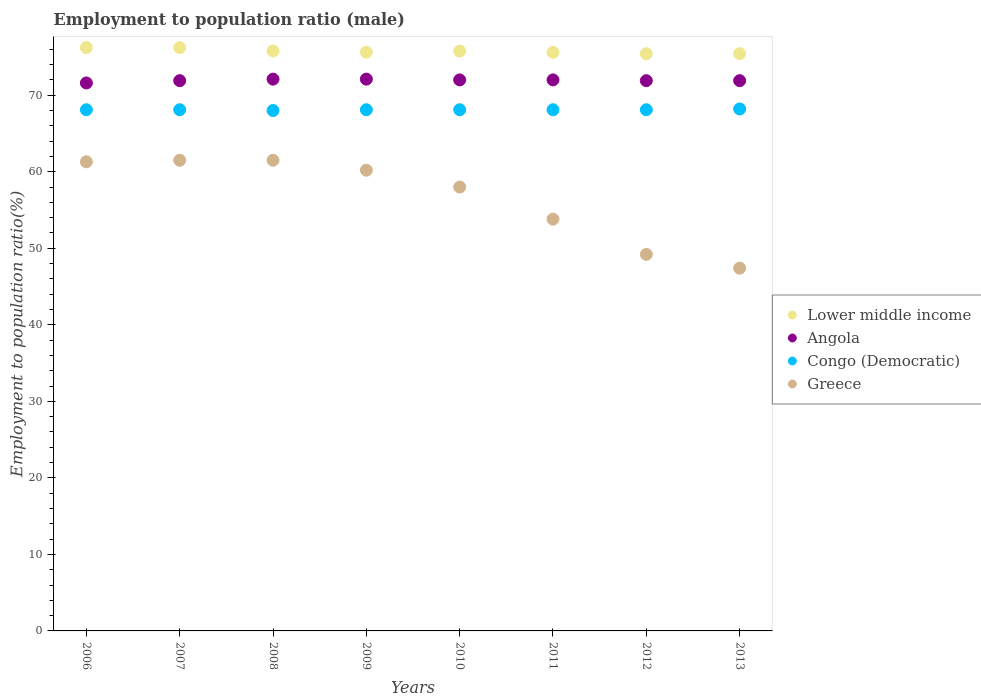What is the employment to population ratio in Greece in 2007?
Keep it short and to the point. 61.5. Across all years, what is the maximum employment to population ratio in Greece?
Offer a terse response. 61.5. Across all years, what is the minimum employment to population ratio in Lower middle income?
Provide a succinct answer. 75.42. In which year was the employment to population ratio in Angola minimum?
Your answer should be compact. 2006. What is the total employment to population ratio in Greece in the graph?
Provide a short and direct response. 452.9. What is the difference between the employment to population ratio in Lower middle income in 2009 and that in 2011?
Keep it short and to the point. 0.02. What is the difference between the employment to population ratio in Congo (Democratic) in 2013 and the employment to population ratio in Greece in 2012?
Keep it short and to the point. 19. What is the average employment to population ratio in Angola per year?
Provide a short and direct response. 71.94. In the year 2013, what is the difference between the employment to population ratio in Congo (Democratic) and employment to population ratio in Angola?
Offer a very short reply. -3.7. What is the ratio of the employment to population ratio in Congo (Democratic) in 2006 to that in 2008?
Your answer should be compact. 1. What is the difference between the highest and the second highest employment to population ratio in Congo (Democratic)?
Offer a terse response. 0.1. In how many years, is the employment to population ratio in Greece greater than the average employment to population ratio in Greece taken over all years?
Provide a succinct answer. 5. Does the employment to population ratio in Congo (Democratic) monotonically increase over the years?
Give a very brief answer. No. How many dotlines are there?
Your answer should be very brief. 4. Are the values on the major ticks of Y-axis written in scientific E-notation?
Your response must be concise. No. Does the graph contain any zero values?
Give a very brief answer. No. Where does the legend appear in the graph?
Give a very brief answer. Center right. How many legend labels are there?
Offer a very short reply. 4. What is the title of the graph?
Your answer should be compact. Employment to population ratio (male). Does "Virgin Islands" appear as one of the legend labels in the graph?
Provide a short and direct response. No. What is the label or title of the X-axis?
Provide a short and direct response. Years. What is the Employment to population ratio(%) of Lower middle income in 2006?
Offer a very short reply. 76.22. What is the Employment to population ratio(%) of Angola in 2006?
Offer a very short reply. 71.6. What is the Employment to population ratio(%) in Congo (Democratic) in 2006?
Ensure brevity in your answer.  68.1. What is the Employment to population ratio(%) in Greece in 2006?
Offer a very short reply. 61.3. What is the Employment to population ratio(%) in Lower middle income in 2007?
Keep it short and to the point. 76.22. What is the Employment to population ratio(%) of Angola in 2007?
Your answer should be compact. 71.9. What is the Employment to population ratio(%) in Congo (Democratic) in 2007?
Your answer should be compact. 68.1. What is the Employment to population ratio(%) of Greece in 2007?
Provide a short and direct response. 61.5. What is the Employment to population ratio(%) in Lower middle income in 2008?
Your answer should be compact. 75.78. What is the Employment to population ratio(%) in Angola in 2008?
Offer a very short reply. 72.1. What is the Employment to population ratio(%) of Greece in 2008?
Provide a succinct answer. 61.5. What is the Employment to population ratio(%) in Lower middle income in 2009?
Provide a short and direct response. 75.62. What is the Employment to population ratio(%) in Angola in 2009?
Offer a very short reply. 72.1. What is the Employment to population ratio(%) in Congo (Democratic) in 2009?
Keep it short and to the point. 68.1. What is the Employment to population ratio(%) in Greece in 2009?
Offer a very short reply. 60.2. What is the Employment to population ratio(%) in Lower middle income in 2010?
Provide a succinct answer. 75.76. What is the Employment to population ratio(%) of Congo (Democratic) in 2010?
Provide a short and direct response. 68.1. What is the Employment to population ratio(%) of Lower middle income in 2011?
Make the answer very short. 75.6. What is the Employment to population ratio(%) in Angola in 2011?
Provide a succinct answer. 72. What is the Employment to population ratio(%) of Congo (Democratic) in 2011?
Your answer should be compact. 68.1. What is the Employment to population ratio(%) of Greece in 2011?
Provide a short and direct response. 53.8. What is the Employment to population ratio(%) in Lower middle income in 2012?
Your response must be concise. 75.42. What is the Employment to population ratio(%) in Angola in 2012?
Your answer should be very brief. 71.9. What is the Employment to population ratio(%) in Congo (Democratic) in 2012?
Your answer should be very brief. 68.1. What is the Employment to population ratio(%) in Greece in 2012?
Provide a short and direct response. 49.2. What is the Employment to population ratio(%) in Lower middle income in 2013?
Keep it short and to the point. 75.43. What is the Employment to population ratio(%) of Angola in 2013?
Your response must be concise. 71.9. What is the Employment to population ratio(%) of Congo (Democratic) in 2013?
Provide a short and direct response. 68.2. What is the Employment to population ratio(%) of Greece in 2013?
Provide a succinct answer. 47.4. Across all years, what is the maximum Employment to population ratio(%) of Lower middle income?
Ensure brevity in your answer.  76.22. Across all years, what is the maximum Employment to population ratio(%) of Angola?
Your response must be concise. 72.1. Across all years, what is the maximum Employment to population ratio(%) in Congo (Democratic)?
Your response must be concise. 68.2. Across all years, what is the maximum Employment to population ratio(%) of Greece?
Keep it short and to the point. 61.5. Across all years, what is the minimum Employment to population ratio(%) of Lower middle income?
Offer a very short reply. 75.42. Across all years, what is the minimum Employment to population ratio(%) of Angola?
Your response must be concise. 71.6. Across all years, what is the minimum Employment to population ratio(%) in Congo (Democratic)?
Provide a short and direct response. 68. Across all years, what is the minimum Employment to population ratio(%) of Greece?
Your answer should be compact. 47.4. What is the total Employment to population ratio(%) of Lower middle income in the graph?
Provide a short and direct response. 606.04. What is the total Employment to population ratio(%) of Angola in the graph?
Provide a succinct answer. 575.5. What is the total Employment to population ratio(%) in Congo (Democratic) in the graph?
Ensure brevity in your answer.  544.8. What is the total Employment to population ratio(%) in Greece in the graph?
Your answer should be very brief. 452.9. What is the difference between the Employment to population ratio(%) of Lower middle income in 2006 and that in 2007?
Provide a short and direct response. 0. What is the difference between the Employment to population ratio(%) in Angola in 2006 and that in 2007?
Provide a succinct answer. -0.3. What is the difference between the Employment to population ratio(%) in Lower middle income in 2006 and that in 2008?
Make the answer very short. 0.44. What is the difference between the Employment to population ratio(%) of Congo (Democratic) in 2006 and that in 2008?
Give a very brief answer. 0.1. What is the difference between the Employment to population ratio(%) of Lower middle income in 2006 and that in 2009?
Make the answer very short. 0.6. What is the difference between the Employment to population ratio(%) in Angola in 2006 and that in 2009?
Your answer should be very brief. -0.5. What is the difference between the Employment to population ratio(%) in Lower middle income in 2006 and that in 2010?
Give a very brief answer. 0.46. What is the difference between the Employment to population ratio(%) in Greece in 2006 and that in 2010?
Your answer should be very brief. 3.3. What is the difference between the Employment to population ratio(%) in Lower middle income in 2006 and that in 2011?
Your response must be concise. 0.62. What is the difference between the Employment to population ratio(%) of Angola in 2006 and that in 2011?
Offer a very short reply. -0.4. What is the difference between the Employment to population ratio(%) in Congo (Democratic) in 2006 and that in 2011?
Offer a terse response. 0. What is the difference between the Employment to population ratio(%) in Greece in 2006 and that in 2011?
Provide a short and direct response. 7.5. What is the difference between the Employment to population ratio(%) of Lower middle income in 2006 and that in 2012?
Offer a terse response. 0.8. What is the difference between the Employment to population ratio(%) of Greece in 2006 and that in 2012?
Your response must be concise. 12.1. What is the difference between the Employment to population ratio(%) of Lower middle income in 2006 and that in 2013?
Offer a very short reply. 0.79. What is the difference between the Employment to population ratio(%) in Angola in 2006 and that in 2013?
Your answer should be very brief. -0.3. What is the difference between the Employment to population ratio(%) of Greece in 2006 and that in 2013?
Provide a succinct answer. 13.9. What is the difference between the Employment to population ratio(%) of Lower middle income in 2007 and that in 2008?
Offer a terse response. 0.44. What is the difference between the Employment to population ratio(%) of Greece in 2007 and that in 2008?
Provide a short and direct response. 0. What is the difference between the Employment to population ratio(%) of Lower middle income in 2007 and that in 2009?
Ensure brevity in your answer.  0.6. What is the difference between the Employment to population ratio(%) in Congo (Democratic) in 2007 and that in 2009?
Offer a terse response. 0. What is the difference between the Employment to population ratio(%) in Lower middle income in 2007 and that in 2010?
Offer a very short reply. 0.45. What is the difference between the Employment to population ratio(%) of Angola in 2007 and that in 2010?
Keep it short and to the point. -0.1. What is the difference between the Employment to population ratio(%) in Congo (Democratic) in 2007 and that in 2010?
Provide a succinct answer. 0. What is the difference between the Employment to population ratio(%) in Greece in 2007 and that in 2010?
Ensure brevity in your answer.  3.5. What is the difference between the Employment to population ratio(%) of Lower middle income in 2007 and that in 2011?
Your response must be concise. 0.62. What is the difference between the Employment to population ratio(%) of Angola in 2007 and that in 2011?
Make the answer very short. -0.1. What is the difference between the Employment to population ratio(%) in Lower middle income in 2007 and that in 2012?
Your answer should be compact. 0.8. What is the difference between the Employment to population ratio(%) in Angola in 2007 and that in 2012?
Provide a short and direct response. 0. What is the difference between the Employment to population ratio(%) in Lower middle income in 2007 and that in 2013?
Your answer should be compact. 0.79. What is the difference between the Employment to population ratio(%) of Congo (Democratic) in 2007 and that in 2013?
Your answer should be compact. -0.1. What is the difference between the Employment to population ratio(%) in Greece in 2007 and that in 2013?
Make the answer very short. 14.1. What is the difference between the Employment to population ratio(%) in Lower middle income in 2008 and that in 2009?
Provide a succinct answer. 0.16. What is the difference between the Employment to population ratio(%) in Angola in 2008 and that in 2009?
Provide a short and direct response. 0. What is the difference between the Employment to population ratio(%) of Greece in 2008 and that in 2009?
Give a very brief answer. 1.3. What is the difference between the Employment to population ratio(%) of Lower middle income in 2008 and that in 2010?
Offer a very short reply. 0.02. What is the difference between the Employment to population ratio(%) of Angola in 2008 and that in 2010?
Your response must be concise. 0.1. What is the difference between the Employment to population ratio(%) of Congo (Democratic) in 2008 and that in 2010?
Ensure brevity in your answer.  -0.1. What is the difference between the Employment to population ratio(%) in Greece in 2008 and that in 2010?
Offer a terse response. 3.5. What is the difference between the Employment to population ratio(%) of Lower middle income in 2008 and that in 2011?
Provide a short and direct response. 0.18. What is the difference between the Employment to population ratio(%) in Angola in 2008 and that in 2011?
Ensure brevity in your answer.  0.1. What is the difference between the Employment to population ratio(%) of Lower middle income in 2008 and that in 2012?
Provide a short and direct response. 0.36. What is the difference between the Employment to population ratio(%) of Congo (Democratic) in 2008 and that in 2012?
Provide a short and direct response. -0.1. What is the difference between the Employment to population ratio(%) of Lower middle income in 2008 and that in 2013?
Make the answer very short. 0.35. What is the difference between the Employment to population ratio(%) of Lower middle income in 2009 and that in 2010?
Your answer should be very brief. -0.15. What is the difference between the Employment to population ratio(%) in Lower middle income in 2009 and that in 2011?
Your answer should be compact. 0.02. What is the difference between the Employment to population ratio(%) of Congo (Democratic) in 2009 and that in 2011?
Provide a succinct answer. 0. What is the difference between the Employment to population ratio(%) of Greece in 2009 and that in 2011?
Your answer should be very brief. 6.4. What is the difference between the Employment to population ratio(%) of Lower middle income in 2009 and that in 2012?
Ensure brevity in your answer.  0.2. What is the difference between the Employment to population ratio(%) of Congo (Democratic) in 2009 and that in 2012?
Provide a succinct answer. 0. What is the difference between the Employment to population ratio(%) of Lower middle income in 2009 and that in 2013?
Offer a very short reply. 0.19. What is the difference between the Employment to population ratio(%) of Lower middle income in 2010 and that in 2011?
Provide a short and direct response. 0.16. What is the difference between the Employment to population ratio(%) in Angola in 2010 and that in 2011?
Give a very brief answer. 0. What is the difference between the Employment to population ratio(%) of Lower middle income in 2010 and that in 2012?
Offer a terse response. 0.34. What is the difference between the Employment to population ratio(%) in Lower middle income in 2010 and that in 2013?
Your answer should be very brief. 0.34. What is the difference between the Employment to population ratio(%) in Angola in 2010 and that in 2013?
Your response must be concise. 0.1. What is the difference between the Employment to population ratio(%) in Congo (Democratic) in 2010 and that in 2013?
Your answer should be compact. -0.1. What is the difference between the Employment to population ratio(%) in Greece in 2010 and that in 2013?
Provide a short and direct response. 10.6. What is the difference between the Employment to population ratio(%) of Lower middle income in 2011 and that in 2012?
Your answer should be very brief. 0.18. What is the difference between the Employment to population ratio(%) in Greece in 2011 and that in 2012?
Provide a succinct answer. 4.6. What is the difference between the Employment to population ratio(%) of Lower middle income in 2011 and that in 2013?
Offer a very short reply. 0.17. What is the difference between the Employment to population ratio(%) of Congo (Democratic) in 2011 and that in 2013?
Ensure brevity in your answer.  -0.1. What is the difference between the Employment to population ratio(%) in Lower middle income in 2012 and that in 2013?
Your answer should be very brief. -0.01. What is the difference between the Employment to population ratio(%) of Congo (Democratic) in 2012 and that in 2013?
Provide a short and direct response. -0.1. What is the difference between the Employment to population ratio(%) in Lower middle income in 2006 and the Employment to population ratio(%) in Angola in 2007?
Give a very brief answer. 4.32. What is the difference between the Employment to population ratio(%) of Lower middle income in 2006 and the Employment to population ratio(%) of Congo (Democratic) in 2007?
Provide a short and direct response. 8.12. What is the difference between the Employment to population ratio(%) in Lower middle income in 2006 and the Employment to population ratio(%) in Greece in 2007?
Keep it short and to the point. 14.72. What is the difference between the Employment to population ratio(%) in Angola in 2006 and the Employment to population ratio(%) in Congo (Democratic) in 2007?
Offer a very short reply. 3.5. What is the difference between the Employment to population ratio(%) of Congo (Democratic) in 2006 and the Employment to population ratio(%) of Greece in 2007?
Provide a short and direct response. 6.6. What is the difference between the Employment to population ratio(%) in Lower middle income in 2006 and the Employment to population ratio(%) in Angola in 2008?
Offer a very short reply. 4.12. What is the difference between the Employment to population ratio(%) of Lower middle income in 2006 and the Employment to population ratio(%) of Congo (Democratic) in 2008?
Your answer should be compact. 8.22. What is the difference between the Employment to population ratio(%) of Lower middle income in 2006 and the Employment to population ratio(%) of Greece in 2008?
Give a very brief answer. 14.72. What is the difference between the Employment to population ratio(%) in Angola in 2006 and the Employment to population ratio(%) in Congo (Democratic) in 2008?
Make the answer very short. 3.6. What is the difference between the Employment to population ratio(%) in Congo (Democratic) in 2006 and the Employment to population ratio(%) in Greece in 2008?
Your answer should be compact. 6.6. What is the difference between the Employment to population ratio(%) of Lower middle income in 2006 and the Employment to population ratio(%) of Angola in 2009?
Ensure brevity in your answer.  4.12. What is the difference between the Employment to population ratio(%) in Lower middle income in 2006 and the Employment to population ratio(%) in Congo (Democratic) in 2009?
Your answer should be compact. 8.12. What is the difference between the Employment to population ratio(%) in Lower middle income in 2006 and the Employment to population ratio(%) in Greece in 2009?
Provide a succinct answer. 16.02. What is the difference between the Employment to population ratio(%) of Angola in 2006 and the Employment to population ratio(%) of Congo (Democratic) in 2009?
Your answer should be compact. 3.5. What is the difference between the Employment to population ratio(%) in Congo (Democratic) in 2006 and the Employment to population ratio(%) in Greece in 2009?
Your answer should be very brief. 7.9. What is the difference between the Employment to population ratio(%) of Lower middle income in 2006 and the Employment to population ratio(%) of Angola in 2010?
Provide a succinct answer. 4.22. What is the difference between the Employment to population ratio(%) in Lower middle income in 2006 and the Employment to population ratio(%) in Congo (Democratic) in 2010?
Your answer should be compact. 8.12. What is the difference between the Employment to population ratio(%) of Lower middle income in 2006 and the Employment to population ratio(%) of Greece in 2010?
Offer a very short reply. 18.22. What is the difference between the Employment to population ratio(%) of Lower middle income in 2006 and the Employment to population ratio(%) of Angola in 2011?
Your answer should be compact. 4.22. What is the difference between the Employment to population ratio(%) of Lower middle income in 2006 and the Employment to population ratio(%) of Congo (Democratic) in 2011?
Your answer should be compact. 8.12. What is the difference between the Employment to population ratio(%) in Lower middle income in 2006 and the Employment to population ratio(%) in Greece in 2011?
Offer a very short reply. 22.42. What is the difference between the Employment to population ratio(%) of Congo (Democratic) in 2006 and the Employment to population ratio(%) of Greece in 2011?
Keep it short and to the point. 14.3. What is the difference between the Employment to population ratio(%) in Lower middle income in 2006 and the Employment to population ratio(%) in Angola in 2012?
Your answer should be compact. 4.32. What is the difference between the Employment to population ratio(%) in Lower middle income in 2006 and the Employment to population ratio(%) in Congo (Democratic) in 2012?
Provide a succinct answer. 8.12. What is the difference between the Employment to population ratio(%) of Lower middle income in 2006 and the Employment to population ratio(%) of Greece in 2012?
Give a very brief answer. 27.02. What is the difference between the Employment to population ratio(%) of Angola in 2006 and the Employment to population ratio(%) of Greece in 2012?
Ensure brevity in your answer.  22.4. What is the difference between the Employment to population ratio(%) in Congo (Democratic) in 2006 and the Employment to population ratio(%) in Greece in 2012?
Your answer should be compact. 18.9. What is the difference between the Employment to population ratio(%) of Lower middle income in 2006 and the Employment to population ratio(%) of Angola in 2013?
Your answer should be very brief. 4.32. What is the difference between the Employment to population ratio(%) in Lower middle income in 2006 and the Employment to population ratio(%) in Congo (Democratic) in 2013?
Your answer should be compact. 8.02. What is the difference between the Employment to population ratio(%) in Lower middle income in 2006 and the Employment to population ratio(%) in Greece in 2013?
Ensure brevity in your answer.  28.82. What is the difference between the Employment to population ratio(%) in Angola in 2006 and the Employment to population ratio(%) in Congo (Democratic) in 2013?
Give a very brief answer. 3.4. What is the difference between the Employment to population ratio(%) in Angola in 2006 and the Employment to population ratio(%) in Greece in 2013?
Make the answer very short. 24.2. What is the difference between the Employment to population ratio(%) of Congo (Democratic) in 2006 and the Employment to population ratio(%) of Greece in 2013?
Your answer should be compact. 20.7. What is the difference between the Employment to population ratio(%) of Lower middle income in 2007 and the Employment to population ratio(%) of Angola in 2008?
Provide a succinct answer. 4.12. What is the difference between the Employment to population ratio(%) of Lower middle income in 2007 and the Employment to population ratio(%) of Congo (Democratic) in 2008?
Your response must be concise. 8.22. What is the difference between the Employment to population ratio(%) in Lower middle income in 2007 and the Employment to population ratio(%) in Greece in 2008?
Offer a very short reply. 14.72. What is the difference between the Employment to population ratio(%) of Angola in 2007 and the Employment to population ratio(%) of Congo (Democratic) in 2008?
Ensure brevity in your answer.  3.9. What is the difference between the Employment to population ratio(%) in Lower middle income in 2007 and the Employment to population ratio(%) in Angola in 2009?
Give a very brief answer. 4.12. What is the difference between the Employment to population ratio(%) in Lower middle income in 2007 and the Employment to population ratio(%) in Congo (Democratic) in 2009?
Give a very brief answer. 8.12. What is the difference between the Employment to population ratio(%) in Lower middle income in 2007 and the Employment to population ratio(%) in Greece in 2009?
Make the answer very short. 16.02. What is the difference between the Employment to population ratio(%) in Angola in 2007 and the Employment to population ratio(%) in Greece in 2009?
Keep it short and to the point. 11.7. What is the difference between the Employment to population ratio(%) of Lower middle income in 2007 and the Employment to population ratio(%) of Angola in 2010?
Give a very brief answer. 4.22. What is the difference between the Employment to population ratio(%) in Lower middle income in 2007 and the Employment to population ratio(%) in Congo (Democratic) in 2010?
Your answer should be compact. 8.12. What is the difference between the Employment to population ratio(%) in Lower middle income in 2007 and the Employment to population ratio(%) in Greece in 2010?
Your answer should be compact. 18.22. What is the difference between the Employment to population ratio(%) of Angola in 2007 and the Employment to population ratio(%) of Congo (Democratic) in 2010?
Ensure brevity in your answer.  3.8. What is the difference between the Employment to population ratio(%) in Angola in 2007 and the Employment to population ratio(%) in Greece in 2010?
Your answer should be very brief. 13.9. What is the difference between the Employment to population ratio(%) of Congo (Democratic) in 2007 and the Employment to population ratio(%) of Greece in 2010?
Provide a short and direct response. 10.1. What is the difference between the Employment to population ratio(%) in Lower middle income in 2007 and the Employment to population ratio(%) in Angola in 2011?
Make the answer very short. 4.22. What is the difference between the Employment to population ratio(%) in Lower middle income in 2007 and the Employment to population ratio(%) in Congo (Democratic) in 2011?
Give a very brief answer. 8.12. What is the difference between the Employment to population ratio(%) in Lower middle income in 2007 and the Employment to population ratio(%) in Greece in 2011?
Provide a short and direct response. 22.42. What is the difference between the Employment to population ratio(%) in Congo (Democratic) in 2007 and the Employment to population ratio(%) in Greece in 2011?
Offer a very short reply. 14.3. What is the difference between the Employment to population ratio(%) of Lower middle income in 2007 and the Employment to population ratio(%) of Angola in 2012?
Your response must be concise. 4.32. What is the difference between the Employment to population ratio(%) in Lower middle income in 2007 and the Employment to population ratio(%) in Congo (Democratic) in 2012?
Ensure brevity in your answer.  8.12. What is the difference between the Employment to population ratio(%) of Lower middle income in 2007 and the Employment to population ratio(%) of Greece in 2012?
Offer a terse response. 27.02. What is the difference between the Employment to population ratio(%) in Angola in 2007 and the Employment to population ratio(%) in Congo (Democratic) in 2012?
Provide a short and direct response. 3.8. What is the difference between the Employment to population ratio(%) in Angola in 2007 and the Employment to population ratio(%) in Greece in 2012?
Your answer should be very brief. 22.7. What is the difference between the Employment to population ratio(%) of Lower middle income in 2007 and the Employment to population ratio(%) of Angola in 2013?
Offer a very short reply. 4.32. What is the difference between the Employment to population ratio(%) in Lower middle income in 2007 and the Employment to population ratio(%) in Congo (Democratic) in 2013?
Provide a short and direct response. 8.02. What is the difference between the Employment to population ratio(%) in Lower middle income in 2007 and the Employment to population ratio(%) in Greece in 2013?
Ensure brevity in your answer.  28.82. What is the difference between the Employment to population ratio(%) in Congo (Democratic) in 2007 and the Employment to population ratio(%) in Greece in 2013?
Offer a very short reply. 20.7. What is the difference between the Employment to population ratio(%) of Lower middle income in 2008 and the Employment to population ratio(%) of Angola in 2009?
Offer a very short reply. 3.68. What is the difference between the Employment to population ratio(%) in Lower middle income in 2008 and the Employment to population ratio(%) in Congo (Democratic) in 2009?
Keep it short and to the point. 7.68. What is the difference between the Employment to population ratio(%) in Lower middle income in 2008 and the Employment to population ratio(%) in Greece in 2009?
Your response must be concise. 15.58. What is the difference between the Employment to population ratio(%) in Angola in 2008 and the Employment to population ratio(%) in Congo (Democratic) in 2009?
Ensure brevity in your answer.  4. What is the difference between the Employment to population ratio(%) in Lower middle income in 2008 and the Employment to population ratio(%) in Angola in 2010?
Offer a very short reply. 3.78. What is the difference between the Employment to population ratio(%) of Lower middle income in 2008 and the Employment to population ratio(%) of Congo (Democratic) in 2010?
Your answer should be compact. 7.68. What is the difference between the Employment to population ratio(%) in Lower middle income in 2008 and the Employment to population ratio(%) in Greece in 2010?
Give a very brief answer. 17.78. What is the difference between the Employment to population ratio(%) in Angola in 2008 and the Employment to population ratio(%) in Congo (Democratic) in 2010?
Provide a succinct answer. 4. What is the difference between the Employment to population ratio(%) in Congo (Democratic) in 2008 and the Employment to population ratio(%) in Greece in 2010?
Keep it short and to the point. 10. What is the difference between the Employment to population ratio(%) in Lower middle income in 2008 and the Employment to population ratio(%) in Angola in 2011?
Keep it short and to the point. 3.78. What is the difference between the Employment to population ratio(%) in Lower middle income in 2008 and the Employment to population ratio(%) in Congo (Democratic) in 2011?
Provide a short and direct response. 7.68. What is the difference between the Employment to population ratio(%) in Lower middle income in 2008 and the Employment to population ratio(%) in Greece in 2011?
Your answer should be very brief. 21.98. What is the difference between the Employment to population ratio(%) of Angola in 2008 and the Employment to population ratio(%) of Greece in 2011?
Provide a succinct answer. 18.3. What is the difference between the Employment to population ratio(%) of Congo (Democratic) in 2008 and the Employment to population ratio(%) of Greece in 2011?
Offer a very short reply. 14.2. What is the difference between the Employment to population ratio(%) of Lower middle income in 2008 and the Employment to population ratio(%) of Angola in 2012?
Your answer should be very brief. 3.88. What is the difference between the Employment to population ratio(%) of Lower middle income in 2008 and the Employment to population ratio(%) of Congo (Democratic) in 2012?
Offer a very short reply. 7.68. What is the difference between the Employment to population ratio(%) of Lower middle income in 2008 and the Employment to population ratio(%) of Greece in 2012?
Make the answer very short. 26.58. What is the difference between the Employment to population ratio(%) in Angola in 2008 and the Employment to population ratio(%) in Congo (Democratic) in 2012?
Provide a succinct answer. 4. What is the difference between the Employment to population ratio(%) in Angola in 2008 and the Employment to population ratio(%) in Greece in 2012?
Provide a short and direct response. 22.9. What is the difference between the Employment to population ratio(%) in Congo (Democratic) in 2008 and the Employment to population ratio(%) in Greece in 2012?
Offer a terse response. 18.8. What is the difference between the Employment to population ratio(%) of Lower middle income in 2008 and the Employment to population ratio(%) of Angola in 2013?
Ensure brevity in your answer.  3.88. What is the difference between the Employment to population ratio(%) in Lower middle income in 2008 and the Employment to population ratio(%) in Congo (Democratic) in 2013?
Offer a terse response. 7.58. What is the difference between the Employment to population ratio(%) of Lower middle income in 2008 and the Employment to population ratio(%) of Greece in 2013?
Make the answer very short. 28.38. What is the difference between the Employment to population ratio(%) of Angola in 2008 and the Employment to population ratio(%) of Greece in 2013?
Provide a succinct answer. 24.7. What is the difference between the Employment to population ratio(%) in Congo (Democratic) in 2008 and the Employment to population ratio(%) in Greece in 2013?
Provide a succinct answer. 20.6. What is the difference between the Employment to population ratio(%) in Lower middle income in 2009 and the Employment to population ratio(%) in Angola in 2010?
Ensure brevity in your answer.  3.62. What is the difference between the Employment to population ratio(%) in Lower middle income in 2009 and the Employment to population ratio(%) in Congo (Democratic) in 2010?
Offer a very short reply. 7.52. What is the difference between the Employment to population ratio(%) in Lower middle income in 2009 and the Employment to population ratio(%) in Greece in 2010?
Your response must be concise. 17.62. What is the difference between the Employment to population ratio(%) of Angola in 2009 and the Employment to population ratio(%) of Greece in 2010?
Make the answer very short. 14.1. What is the difference between the Employment to population ratio(%) in Congo (Democratic) in 2009 and the Employment to population ratio(%) in Greece in 2010?
Offer a very short reply. 10.1. What is the difference between the Employment to population ratio(%) of Lower middle income in 2009 and the Employment to population ratio(%) of Angola in 2011?
Offer a terse response. 3.62. What is the difference between the Employment to population ratio(%) in Lower middle income in 2009 and the Employment to population ratio(%) in Congo (Democratic) in 2011?
Your answer should be very brief. 7.52. What is the difference between the Employment to population ratio(%) in Lower middle income in 2009 and the Employment to population ratio(%) in Greece in 2011?
Give a very brief answer. 21.82. What is the difference between the Employment to population ratio(%) of Congo (Democratic) in 2009 and the Employment to population ratio(%) of Greece in 2011?
Provide a short and direct response. 14.3. What is the difference between the Employment to population ratio(%) in Lower middle income in 2009 and the Employment to population ratio(%) in Angola in 2012?
Offer a very short reply. 3.72. What is the difference between the Employment to population ratio(%) in Lower middle income in 2009 and the Employment to population ratio(%) in Congo (Democratic) in 2012?
Your response must be concise. 7.52. What is the difference between the Employment to population ratio(%) in Lower middle income in 2009 and the Employment to population ratio(%) in Greece in 2012?
Give a very brief answer. 26.42. What is the difference between the Employment to population ratio(%) of Angola in 2009 and the Employment to population ratio(%) of Congo (Democratic) in 2012?
Your response must be concise. 4. What is the difference between the Employment to population ratio(%) of Angola in 2009 and the Employment to population ratio(%) of Greece in 2012?
Offer a very short reply. 22.9. What is the difference between the Employment to population ratio(%) in Lower middle income in 2009 and the Employment to population ratio(%) in Angola in 2013?
Your answer should be very brief. 3.72. What is the difference between the Employment to population ratio(%) of Lower middle income in 2009 and the Employment to population ratio(%) of Congo (Democratic) in 2013?
Provide a short and direct response. 7.42. What is the difference between the Employment to population ratio(%) in Lower middle income in 2009 and the Employment to population ratio(%) in Greece in 2013?
Keep it short and to the point. 28.22. What is the difference between the Employment to population ratio(%) of Angola in 2009 and the Employment to population ratio(%) of Greece in 2013?
Ensure brevity in your answer.  24.7. What is the difference between the Employment to population ratio(%) of Congo (Democratic) in 2009 and the Employment to population ratio(%) of Greece in 2013?
Offer a very short reply. 20.7. What is the difference between the Employment to population ratio(%) in Lower middle income in 2010 and the Employment to population ratio(%) in Angola in 2011?
Your answer should be very brief. 3.76. What is the difference between the Employment to population ratio(%) of Lower middle income in 2010 and the Employment to population ratio(%) of Congo (Democratic) in 2011?
Provide a succinct answer. 7.66. What is the difference between the Employment to population ratio(%) of Lower middle income in 2010 and the Employment to population ratio(%) of Greece in 2011?
Offer a very short reply. 21.96. What is the difference between the Employment to population ratio(%) in Angola in 2010 and the Employment to population ratio(%) in Congo (Democratic) in 2011?
Your answer should be very brief. 3.9. What is the difference between the Employment to population ratio(%) of Congo (Democratic) in 2010 and the Employment to population ratio(%) of Greece in 2011?
Your answer should be very brief. 14.3. What is the difference between the Employment to population ratio(%) in Lower middle income in 2010 and the Employment to population ratio(%) in Angola in 2012?
Give a very brief answer. 3.86. What is the difference between the Employment to population ratio(%) of Lower middle income in 2010 and the Employment to population ratio(%) of Congo (Democratic) in 2012?
Provide a short and direct response. 7.66. What is the difference between the Employment to population ratio(%) of Lower middle income in 2010 and the Employment to population ratio(%) of Greece in 2012?
Offer a terse response. 26.56. What is the difference between the Employment to population ratio(%) in Angola in 2010 and the Employment to population ratio(%) in Greece in 2012?
Make the answer very short. 22.8. What is the difference between the Employment to population ratio(%) of Lower middle income in 2010 and the Employment to population ratio(%) of Angola in 2013?
Provide a short and direct response. 3.86. What is the difference between the Employment to population ratio(%) of Lower middle income in 2010 and the Employment to population ratio(%) of Congo (Democratic) in 2013?
Your answer should be compact. 7.56. What is the difference between the Employment to population ratio(%) in Lower middle income in 2010 and the Employment to population ratio(%) in Greece in 2013?
Keep it short and to the point. 28.36. What is the difference between the Employment to population ratio(%) in Angola in 2010 and the Employment to population ratio(%) in Congo (Democratic) in 2013?
Offer a very short reply. 3.8. What is the difference between the Employment to population ratio(%) in Angola in 2010 and the Employment to population ratio(%) in Greece in 2013?
Your response must be concise. 24.6. What is the difference between the Employment to population ratio(%) of Congo (Democratic) in 2010 and the Employment to population ratio(%) of Greece in 2013?
Ensure brevity in your answer.  20.7. What is the difference between the Employment to population ratio(%) in Lower middle income in 2011 and the Employment to population ratio(%) in Angola in 2012?
Your response must be concise. 3.7. What is the difference between the Employment to population ratio(%) of Lower middle income in 2011 and the Employment to population ratio(%) of Congo (Democratic) in 2012?
Ensure brevity in your answer.  7.5. What is the difference between the Employment to population ratio(%) in Lower middle income in 2011 and the Employment to population ratio(%) in Greece in 2012?
Ensure brevity in your answer.  26.4. What is the difference between the Employment to population ratio(%) of Angola in 2011 and the Employment to population ratio(%) of Greece in 2012?
Keep it short and to the point. 22.8. What is the difference between the Employment to population ratio(%) in Lower middle income in 2011 and the Employment to population ratio(%) in Angola in 2013?
Ensure brevity in your answer.  3.7. What is the difference between the Employment to population ratio(%) in Lower middle income in 2011 and the Employment to population ratio(%) in Congo (Democratic) in 2013?
Provide a succinct answer. 7.4. What is the difference between the Employment to population ratio(%) of Lower middle income in 2011 and the Employment to population ratio(%) of Greece in 2013?
Your answer should be compact. 28.2. What is the difference between the Employment to population ratio(%) of Angola in 2011 and the Employment to population ratio(%) of Congo (Democratic) in 2013?
Provide a succinct answer. 3.8. What is the difference between the Employment to population ratio(%) of Angola in 2011 and the Employment to population ratio(%) of Greece in 2013?
Give a very brief answer. 24.6. What is the difference between the Employment to population ratio(%) of Congo (Democratic) in 2011 and the Employment to population ratio(%) of Greece in 2013?
Give a very brief answer. 20.7. What is the difference between the Employment to population ratio(%) in Lower middle income in 2012 and the Employment to population ratio(%) in Angola in 2013?
Provide a succinct answer. 3.52. What is the difference between the Employment to population ratio(%) in Lower middle income in 2012 and the Employment to population ratio(%) in Congo (Democratic) in 2013?
Keep it short and to the point. 7.22. What is the difference between the Employment to population ratio(%) of Lower middle income in 2012 and the Employment to population ratio(%) of Greece in 2013?
Your response must be concise. 28.02. What is the difference between the Employment to population ratio(%) in Angola in 2012 and the Employment to population ratio(%) in Congo (Democratic) in 2013?
Your answer should be compact. 3.7. What is the difference between the Employment to population ratio(%) in Congo (Democratic) in 2012 and the Employment to population ratio(%) in Greece in 2013?
Provide a short and direct response. 20.7. What is the average Employment to population ratio(%) in Lower middle income per year?
Provide a short and direct response. 75.76. What is the average Employment to population ratio(%) of Angola per year?
Ensure brevity in your answer.  71.94. What is the average Employment to population ratio(%) of Congo (Democratic) per year?
Give a very brief answer. 68.1. What is the average Employment to population ratio(%) of Greece per year?
Give a very brief answer. 56.61. In the year 2006, what is the difference between the Employment to population ratio(%) in Lower middle income and Employment to population ratio(%) in Angola?
Offer a very short reply. 4.62. In the year 2006, what is the difference between the Employment to population ratio(%) of Lower middle income and Employment to population ratio(%) of Congo (Democratic)?
Your answer should be very brief. 8.12. In the year 2006, what is the difference between the Employment to population ratio(%) of Lower middle income and Employment to population ratio(%) of Greece?
Ensure brevity in your answer.  14.92. In the year 2006, what is the difference between the Employment to population ratio(%) of Angola and Employment to population ratio(%) of Congo (Democratic)?
Give a very brief answer. 3.5. In the year 2007, what is the difference between the Employment to population ratio(%) of Lower middle income and Employment to population ratio(%) of Angola?
Keep it short and to the point. 4.32. In the year 2007, what is the difference between the Employment to population ratio(%) of Lower middle income and Employment to population ratio(%) of Congo (Democratic)?
Your response must be concise. 8.12. In the year 2007, what is the difference between the Employment to population ratio(%) in Lower middle income and Employment to population ratio(%) in Greece?
Ensure brevity in your answer.  14.72. In the year 2007, what is the difference between the Employment to population ratio(%) of Angola and Employment to population ratio(%) of Congo (Democratic)?
Offer a very short reply. 3.8. In the year 2007, what is the difference between the Employment to population ratio(%) in Angola and Employment to population ratio(%) in Greece?
Provide a succinct answer. 10.4. In the year 2007, what is the difference between the Employment to population ratio(%) of Congo (Democratic) and Employment to population ratio(%) of Greece?
Provide a short and direct response. 6.6. In the year 2008, what is the difference between the Employment to population ratio(%) in Lower middle income and Employment to population ratio(%) in Angola?
Offer a very short reply. 3.68. In the year 2008, what is the difference between the Employment to population ratio(%) of Lower middle income and Employment to population ratio(%) of Congo (Democratic)?
Provide a short and direct response. 7.78. In the year 2008, what is the difference between the Employment to population ratio(%) in Lower middle income and Employment to population ratio(%) in Greece?
Your answer should be compact. 14.28. In the year 2009, what is the difference between the Employment to population ratio(%) in Lower middle income and Employment to population ratio(%) in Angola?
Your response must be concise. 3.52. In the year 2009, what is the difference between the Employment to population ratio(%) in Lower middle income and Employment to population ratio(%) in Congo (Democratic)?
Keep it short and to the point. 7.52. In the year 2009, what is the difference between the Employment to population ratio(%) of Lower middle income and Employment to population ratio(%) of Greece?
Ensure brevity in your answer.  15.42. In the year 2009, what is the difference between the Employment to population ratio(%) of Angola and Employment to population ratio(%) of Congo (Democratic)?
Keep it short and to the point. 4. In the year 2009, what is the difference between the Employment to population ratio(%) in Angola and Employment to population ratio(%) in Greece?
Your answer should be compact. 11.9. In the year 2009, what is the difference between the Employment to population ratio(%) in Congo (Democratic) and Employment to population ratio(%) in Greece?
Your response must be concise. 7.9. In the year 2010, what is the difference between the Employment to population ratio(%) in Lower middle income and Employment to population ratio(%) in Angola?
Offer a very short reply. 3.76. In the year 2010, what is the difference between the Employment to population ratio(%) of Lower middle income and Employment to population ratio(%) of Congo (Democratic)?
Provide a succinct answer. 7.66. In the year 2010, what is the difference between the Employment to population ratio(%) of Lower middle income and Employment to population ratio(%) of Greece?
Ensure brevity in your answer.  17.76. In the year 2010, what is the difference between the Employment to population ratio(%) in Angola and Employment to population ratio(%) in Congo (Democratic)?
Give a very brief answer. 3.9. In the year 2010, what is the difference between the Employment to population ratio(%) in Angola and Employment to population ratio(%) in Greece?
Your answer should be very brief. 14. In the year 2010, what is the difference between the Employment to population ratio(%) in Congo (Democratic) and Employment to population ratio(%) in Greece?
Ensure brevity in your answer.  10.1. In the year 2011, what is the difference between the Employment to population ratio(%) of Lower middle income and Employment to population ratio(%) of Angola?
Ensure brevity in your answer.  3.6. In the year 2011, what is the difference between the Employment to population ratio(%) in Lower middle income and Employment to population ratio(%) in Congo (Democratic)?
Your answer should be compact. 7.5. In the year 2011, what is the difference between the Employment to population ratio(%) in Lower middle income and Employment to population ratio(%) in Greece?
Keep it short and to the point. 21.8. In the year 2011, what is the difference between the Employment to population ratio(%) of Angola and Employment to population ratio(%) of Congo (Democratic)?
Provide a short and direct response. 3.9. In the year 2012, what is the difference between the Employment to population ratio(%) in Lower middle income and Employment to population ratio(%) in Angola?
Offer a terse response. 3.52. In the year 2012, what is the difference between the Employment to population ratio(%) of Lower middle income and Employment to population ratio(%) of Congo (Democratic)?
Keep it short and to the point. 7.32. In the year 2012, what is the difference between the Employment to population ratio(%) in Lower middle income and Employment to population ratio(%) in Greece?
Provide a succinct answer. 26.22. In the year 2012, what is the difference between the Employment to population ratio(%) of Angola and Employment to population ratio(%) of Congo (Democratic)?
Make the answer very short. 3.8. In the year 2012, what is the difference between the Employment to population ratio(%) of Angola and Employment to population ratio(%) of Greece?
Provide a short and direct response. 22.7. In the year 2013, what is the difference between the Employment to population ratio(%) of Lower middle income and Employment to population ratio(%) of Angola?
Ensure brevity in your answer.  3.53. In the year 2013, what is the difference between the Employment to population ratio(%) in Lower middle income and Employment to population ratio(%) in Congo (Democratic)?
Ensure brevity in your answer.  7.23. In the year 2013, what is the difference between the Employment to population ratio(%) of Lower middle income and Employment to population ratio(%) of Greece?
Give a very brief answer. 28.03. In the year 2013, what is the difference between the Employment to population ratio(%) of Congo (Democratic) and Employment to population ratio(%) of Greece?
Offer a terse response. 20.8. What is the ratio of the Employment to population ratio(%) of Lower middle income in 2006 to that in 2007?
Your answer should be very brief. 1. What is the ratio of the Employment to population ratio(%) of Congo (Democratic) in 2006 to that in 2007?
Make the answer very short. 1. What is the ratio of the Employment to population ratio(%) in Greece in 2006 to that in 2008?
Offer a terse response. 1. What is the ratio of the Employment to population ratio(%) in Lower middle income in 2006 to that in 2009?
Provide a short and direct response. 1.01. What is the ratio of the Employment to population ratio(%) in Angola in 2006 to that in 2009?
Your answer should be compact. 0.99. What is the ratio of the Employment to population ratio(%) in Congo (Democratic) in 2006 to that in 2009?
Offer a very short reply. 1. What is the ratio of the Employment to population ratio(%) of Greece in 2006 to that in 2009?
Make the answer very short. 1.02. What is the ratio of the Employment to population ratio(%) in Lower middle income in 2006 to that in 2010?
Offer a very short reply. 1.01. What is the ratio of the Employment to population ratio(%) in Greece in 2006 to that in 2010?
Your answer should be compact. 1.06. What is the ratio of the Employment to population ratio(%) of Lower middle income in 2006 to that in 2011?
Offer a very short reply. 1.01. What is the ratio of the Employment to population ratio(%) of Angola in 2006 to that in 2011?
Give a very brief answer. 0.99. What is the ratio of the Employment to population ratio(%) of Greece in 2006 to that in 2011?
Keep it short and to the point. 1.14. What is the ratio of the Employment to population ratio(%) in Lower middle income in 2006 to that in 2012?
Your answer should be compact. 1.01. What is the ratio of the Employment to population ratio(%) of Angola in 2006 to that in 2012?
Offer a terse response. 1. What is the ratio of the Employment to population ratio(%) of Congo (Democratic) in 2006 to that in 2012?
Keep it short and to the point. 1. What is the ratio of the Employment to population ratio(%) in Greece in 2006 to that in 2012?
Your answer should be compact. 1.25. What is the ratio of the Employment to population ratio(%) of Lower middle income in 2006 to that in 2013?
Your response must be concise. 1.01. What is the ratio of the Employment to population ratio(%) of Congo (Democratic) in 2006 to that in 2013?
Your answer should be very brief. 1. What is the ratio of the Employment to population ratio(%) in Greece in 2006 to that in 2013?
Offer a very short reply. 1.29. What is the ratio of the Employment to population ratio(%) in Lower middle income in 2007 to that in 2008?
Keep it short and to the point. 1.01. What is the ratio of the Employment to population ratio(%) of Angola in 2007 to that in 2008?
Ensure brevity in your answer.  1. What is the ratio of the Employment to population ratio(%) of Lower middle income in 2007 to that in 2009?
Your answer should be very brief. 1.01. What is the ratio of the Employment to population ratio(%) in Angola in 2007 to that in 2009?
Your response must be concise. 1. What is the ratio of the Employment to population ratio(%) in Greece in 2007 to that in 2009?
Provide a succinct answer. 1.02. What is the ratio of the Employment to population ratio(%) of Lower middle income in 2007 to that in 2010?
Give a very brief answer. 1.01. What is the ratio of the Employment to population ratio(%) in Angola in 2007 to that in 2010?
Your response must be concise. 1. What is the ratio of the Employment to population ratio(%) of Greece in 2007 to that in 2010?
Your answer should be very brief. 1.06. What is the ratio of the Employment to population ratio(%) of Lower middle income in 2007 to that in 2011?
Provide a short and direct response. 1.01. What is the ratio of the Employment to population ratio(%) in Angola in 2007 to that in 2011?
Offer a very short reply. 1. What is the ratio of the Employment to population ratio(%) in Greece in 2007 to that in 2011?
Ensure brevity in your answer.  1.14. What is the ratio of the Employment to population ratio(%) of Lower middle income in 2007 to that in 2012?
Give a very brief answer. 1.01. What is the ratio of the Employment to population ratio(%) in Congo (Democratic) in 2007 to that in 2012?
Offer a terse response. 1. What is the ratio of the Employment to population ratio(%) of Greece in 2007 to that in 2012?
Offer a terse response. 1.25. What is the ratio of the Employment to population ratio(%) of Lower middle income in 2007 to that in 2013?
Provide a succinct answer. 1.01. What is the ratio of the Employment to population ratio(%) in Angola in 2007 to that in 2013?
Your answer should be very brief. 1. What is the ratio of the Employment to population ratio(%) of Greece in 2007 to that in 2013?
Make the answer very short. 1.3. What is the ratio of the Employment to population ratio(%) of Angola in 2008 to that in 2009?
Ensure brevity in your answer.  1. What is the ratio of the Employment to population ratio(%) in Congo (Democratic) in 2008 to that in 2009?
Offer a very short reply. 1. What is the ratio of the Employment to population ratio(%) in Greece in 2008 to that in 2009?
Provide a short and direct response. 1.02. What is the ratio of the Employment to population ratio(%) in Congo (Democratic) in 2008 to that in 2010?
Offer a very short reply. 1. What is the ratio of the Employment to population ratio(%) in Greece in 2008 to that in 2010?
Provide a succinct answer. 1.06. What is the ratio of the Employment to population ratio(%) in Lower middle income in 2008 to that in 2011?
Make the answer very short. 1. What is the ratio of the Employment to population ratio(%) of Angola in 2008 to that in 2011?
Keep it short and to the point. 1. What is the ratio of the Employment to population ratio(%) in Greece in 2008 to that in 2011?
Provide a short and direct response. 1.14. What is the ratio of the Employment to population ratio(%) in Lower middle income in 2008 to that in 2012?
Keep it short and to the point. 1. What is the ratio of the Employment to population ratio(%) of Angola in 2008 to that in 2012?
Your answer should be very brief. 1. What is the ratio of the Employment to population ratio(%) of Congo (Democratic) in 2008 to that in 2012?
Ensure brevity in your answer.  1. What is the ratio of the Employment to population ratio(%) of Greece in 2008 to that in 2012?
Provide a succinct answer. 1.25. What is the ratio of the Employment to population ratio(%) in Congo (Democratic) in 2008 to that in 2013?
Your answer should be very brief. 1. What is the ratio of the Employment to population ratio(%) of Greece in 2008 to that in 2013?
Make the answer very short. 1.3. What is the ratio of the Employment to population ratio(%) of Lower middle income in 2009 to that in 2010?
Ensure brevity in your answer.  1. What is the ratio of the Employment to population ratio(%) in Greece in 2009 to that in 2010?
Your answer should be very brief. 1.04. What is the ratio of the Employment to population ratio(%) of Greece in 2009 to that in 2011?
Offer a terse response. 1.12. What is the ratio of the Employment to population ratio(%) in Lower middle income in 2009 to that in 2012?
Provide a short and direct response. 1. What is the ratio of the Employment to population ratio(%) of Congo (Democratic) in 2009 to that in 2012?
Your answer should be compact. 1. What is the ratio of the Employment to population ratio(%) in Greece in 2009 to that in 2012?
Your response must be concise. 1.22. What is the ratio of the Employment to population ratio(%) in Greece in 2009 to that in 2013?
Offer a terse response. 1.27. What is the ratio of the Employment to population ratio(%) of Greece in 2010 to that in 2011?
Provide a short and direct response. 1.08. What is the ratio of the Employment to population ratio(%) of Angola in 2010 to that in 2012?
Give a very brief answer. 1. What is the ratio of the Employment to population ratio(%) in Greece in 2010 to that in 2012?
Provide a succinct answer. 1.18. What is the ratio of the Employment to population ratio(%) in Congo (Democratic) in 2010 to that in 2013?
Ensure brevity in your answer.  1. What is the ratio of the Employment to population ratio(%) in Greece in 2010 to that in 2013?
Make the answer very short. 1.22. What is the ratio of the Employment to population ratio(%) in Congo (Democratic) in 2011 to that in 2012?
Give a very brief answer. 1. What is the ratio of the Employment to population ratio(%) in Greece in 2011 to that in 2012?
Your answer should be compact. 1.09. What is the ratio of the Employment to population ratio(%) in Greece in 2011 to that in 2013?
Offer a very short reply. 1.14. What is the ratio of the Employment to population ratio(%) of Lower middle income in 2012 to that in 2013?
Give a very brief answer. 1. What is the ratio of the Employment to population ratio(%) of Greece in 2012 to that in 2013?
Offer a terse response. 1.04. What is the difference between the highest and the second highest Employment to population ratio(%) of Lower middle income?
Offer a terse response. 0. What is the difference between the highest and the lowest Employment to population ratio(%) in Lower middle income?
Your response must be concise. 0.8. What is the difference between the highest and the lowest Employment to population ratio(%) of Angola?
Provide a succinct answer. 0.5. 